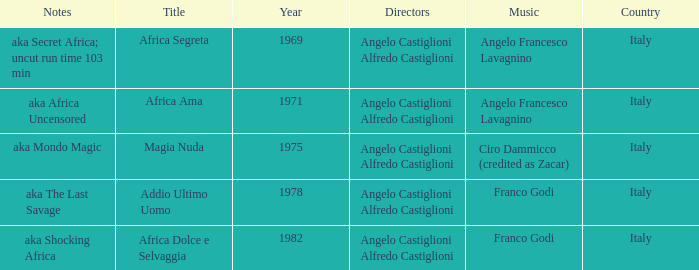Which music has the notes of AKA Africa Uncensored? Angelo Francesco Lavagnino. Write the full table. {'header': ['Notes', 'Title', 'Year', 'Directors', 'Music', 'Country'], 'rows': [['aka Secret Africa; uncut run time 103 min', 'Africa Segreta', '1969', 'Angelo Castiglioni Alfredo Castiglioni', 'Angelo Francesco Lavagnino', 'Italy'], ['aka Africa Uncensored', 'Africa Ama', '1971', 'Angelo Castiglioni Alfredo Castiglioni', 'Angelo Francesco Lavagnino', 'Italy'], ['aka Mondo Magic', 'Magia Nuda', '1975', 'Angelo Castiglioni Alfredo Castiglioni', 'Ciro Dammicco (credited as Zacar)', 'Italy'], ['aka The Last Savage', 'Addio Ultimo Uomo', '1978', 'Angelo Castiglioni Alfredo Castiglioni', 'Franco Godi', 'Italy'], ['aka Shocking Africa', 'Africa Dolce e Selvaggia', '1982', 'Angelo Castiglioni Alfredo Castiglioni', 'Franco Godi', 'Italy']]} 